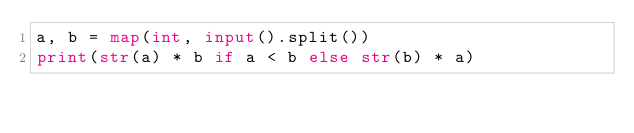<code> <loc_0><loc_0><loc_500><loc_500><_Python_>a, b = map(int, input().split())
print(str(a) * b if a < b else str(b) * a)</code> 